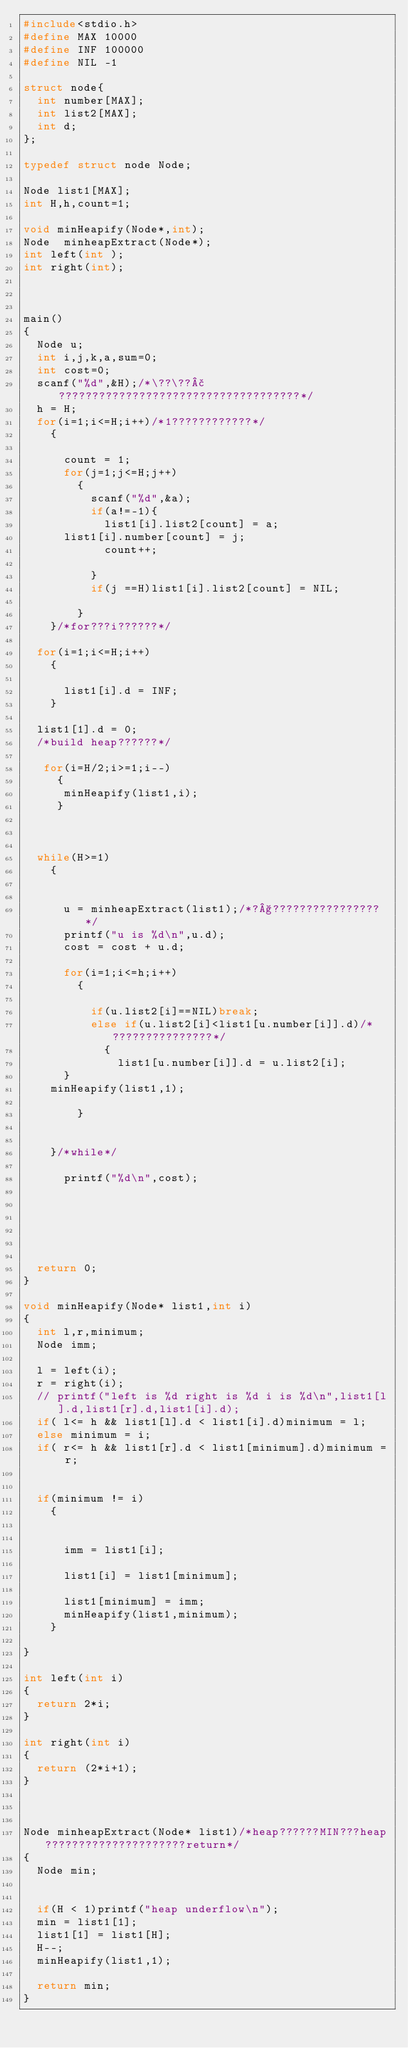Convert code to text. <code><loc_0><loc_0><loc_500><loc_500><_C_>#include<stdio.h>
#define MAX 10000
#define INF 100000
#define NIL -1

struct node{
  int number[MAX];
  int list2[MAX];
  int d;
};

typedef struct node Node;

Node list1[MAX];
int H,h,count=1;

void minHeapify(Node*,int);
Node  minheapExtract(Node*);
int left(int );
int right(int);



main()
{
  Node u;
  int i,j,k,a,sum=0;
  int cost=0;
  scanf("%d",&H);/*\??\??£????????????????????????????????????*/
  h = H;
  for(i=1;i<=H;i++)/*1????????????*/
    {
      
      count = 1;
      for(j=1;j<=H;j++)
        {
          scanf("%d",&a);
          if(a!=-1){
            list1[i].list2[count] = a;
	    list1[i].number[count] = j;
            count++;

          }
          if(j ==H)list1[i].list2[count] = NIL;
         
        }
    }/*for???i??????*/

  for(i=1;i<=H;i++)
    {
      
      list1[i].d = INF;
    }

  list1[1].d = 0;
  /*build heap??????*/

   for(i=H/2;i>=1;i--)
     {
      minHeapify(list1,i);
     }  

   

  while(H>=1)
    {
      
      
      u = minheapExtract(list1);/*?§????????????????*/
      printf("u is %d\n",u.d);
      cost = cost + u.d;
      
      for(i=1;i<=h;i++)
        {
          
          if(u.list2[i]==NIL)break;
          else if(u.list2[i]<list1[u.number[i]].d)/*???????????????*/
            {
              list1[u.number[i]].d = u.list2[i];
	    }
	  minHeapify(list1,1);                
            
        }
    
      
    }/*while*/

      printf("%d\n",cost);
     
    

  


  return 0;
}

void minHeapify(Node* list1,int i)
{
  int l,r,minimum;
  Node imm;

  l = left(i);      
  r = right(i);
  // printf("left is %d right is %d i is %d\n",list1[l].d,list1[r].d,list1[i].d);
  if( l<= h && list1[l].d < list1[i].d)minimum = l;
  else minimum = i;
  if( r<= h && list1[r].d < list1[minimum].d)minimum = r;

 
  if(minimum != i)
    {
      
   
      imm = list1[i];
  
      list1[i] = list1[minimum];
 
      list1[minimum] = imm;
      minHeapify(list1,minimum);
    }

}

int left(int i)
{
  return 2*i;
}

int right(int i)
{
  return (2*i+1);
}



Node minheapExtract(Node* list1)/*heap??????MIN???heap?????????????????????return*/
{
  Node min;
  

  if(H < 1)printf("heap underflow\n");
  min = list1[1];
  list1[1] = list1[H];
  H--;
  minHeapify(list1,1);

  return min;
}</code> 